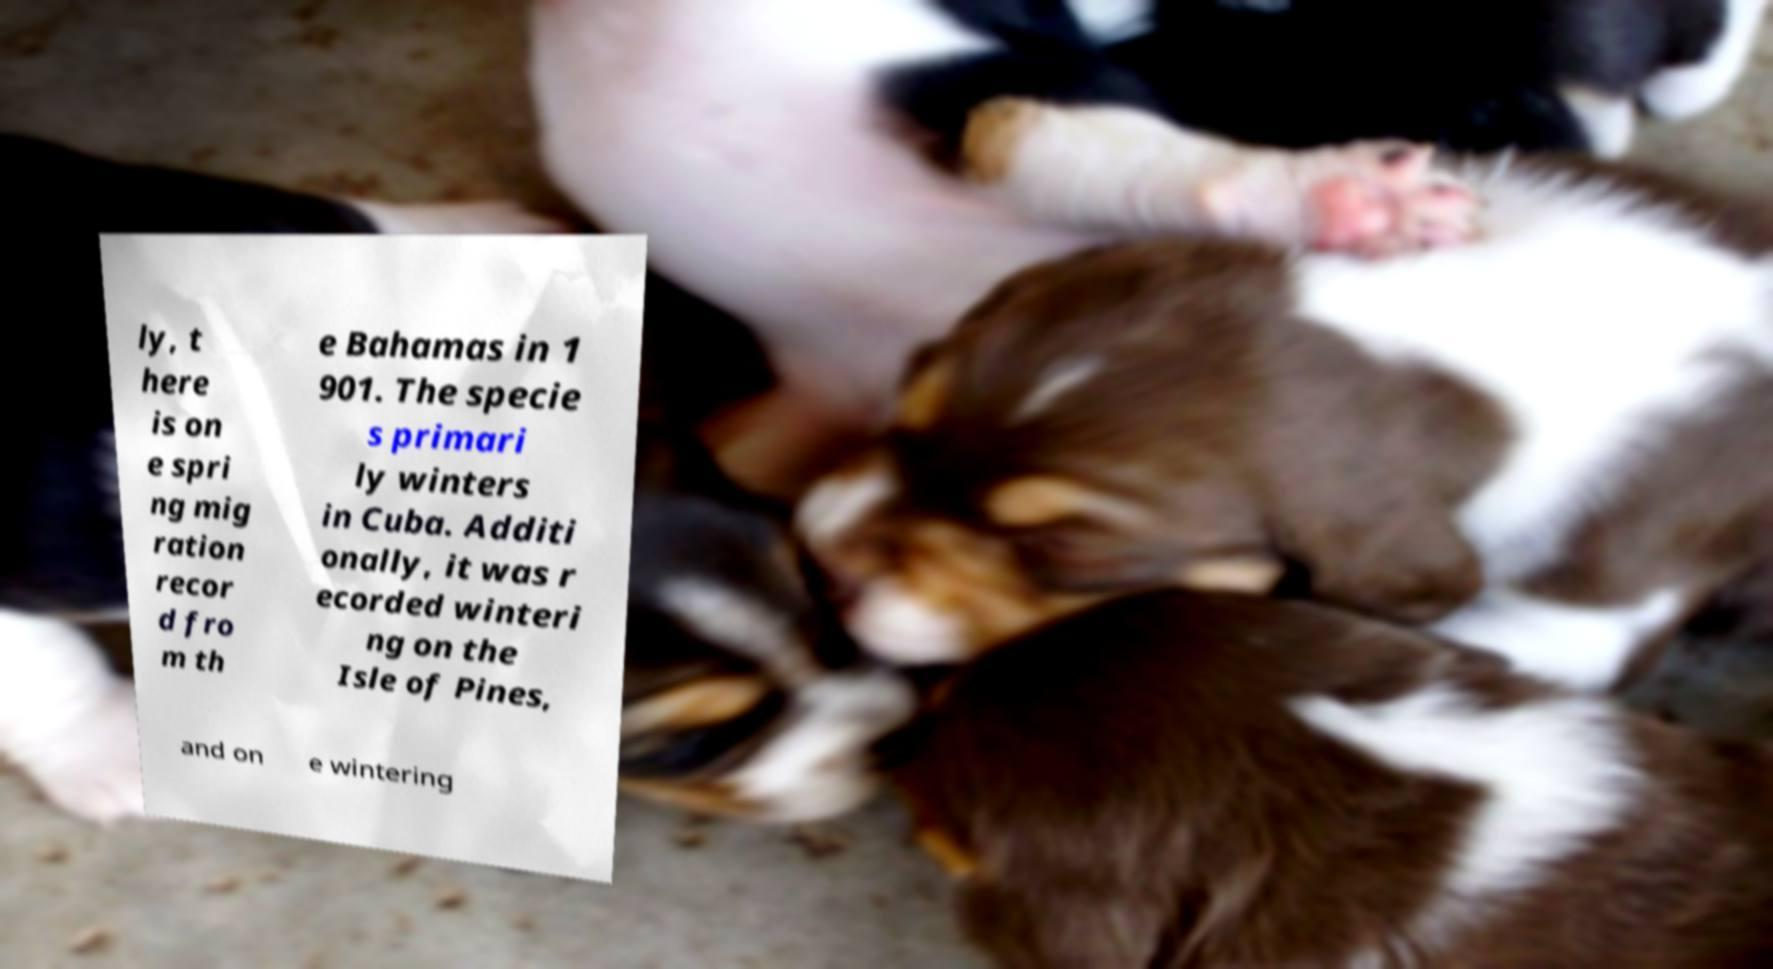Please read and relay the text visible in this image. What does it say? ly, t here is on e spri ng mig ration recor d fro m th e Bahamas in 1 901. The specie s primari ly winters in Cuba. Additi onally, it was r ecorded winteri ng on the Isle of Pines, and on e wintering 